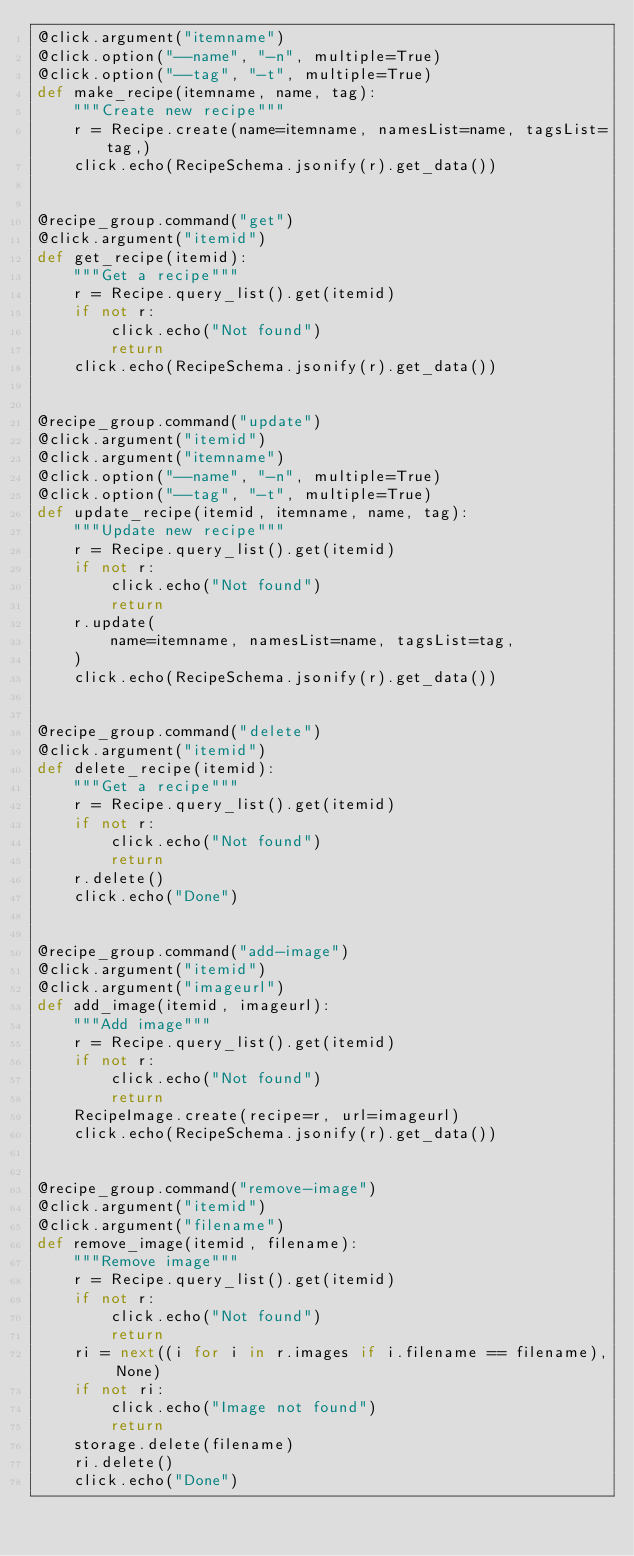<code> <loc_0><loc_0><loc_500><loc_500><_Python_>@click.argument("itemname")
@click.option("--name", "-n", multiple=True)
@click.option("--tag", "-t", multiple=True)
def make_recipe(itemname, name, tag):
    """Create new recipe"""
    r = Recipe.create(name=itemname, namesList=name, tagsList=tag,)
    click.echo(RecipeSchema.jsonify(r).get_data())


@recipe_group.command("get")
@click.argument("itemid")
def get_recipe(itemid):
    """Get a recipe"""
    r = Recipe.query_list().get(itemid)
    if not r:
        click.echo("Not found")
        return
    click.echo(RecipeSchema.jsonify(r).get_data())


@recipe_group.command("update")
@click.argument("itemid")
@click.argument("itemname")
@click.option("--name", "-n", multiple=True)
@click.option("--tag", "-t", multiple=True)
def update_recipe(itemid, itemname, name, tag):
    """Update new recipe"""
    r = Recipe.query_list().get(itemid)
    if not r:
        click.echo("Not found")
        return
    r.update(
        name=itemname, namesList=name, tagsList=tag,
    )
    click.echo(RecipeSchema.jsonify(r).get_data())


@recipe_group.command("delete")
@click.argument("itemid")
def delete_recipe(itemid):
    """Get a recipe"""
    r = Recipe.query_list().get(itemid)
    if not r:
        click.echo("Not found")
        return
    r.delete()
    click.echo("Done")


@recipe_group.command("add-image")
@click.argument("itemid")
@click.argument("imageurl")
def add_image(itemid, imageurl):
    """Add image"""
    r = Recipe.query_list().get(itemid)
    if not r:
        click.echo("Not found")
        return
    RecipeImage.create(recipe=r, url=imageurl)
    click.echo(RecipeSchema.jsonify(r).get_data())


@recipe_group.command("remove-image")
@click.argument("itemid")
@click.argument("filename")
def remove_image(itemid, filename):
    """Remove image"""
    r = Recipe.query_list().get(itemid)
    if not r:
        click.echo("Not found")
        return
    ri = next((i for i in r.images if i.filename == filename), None)
    if not ri:
        click.echo("Image not found")
        return
    storage.delete(filename)
    ri.delete()
    click.echo("Done")
</code> 